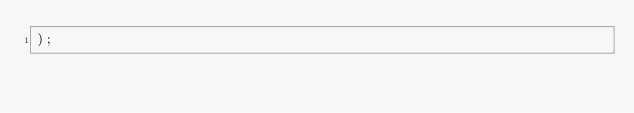Convert code to text. <code><loc_0><loc_0><loc_500><loc_500><_SQL_>);</code> 